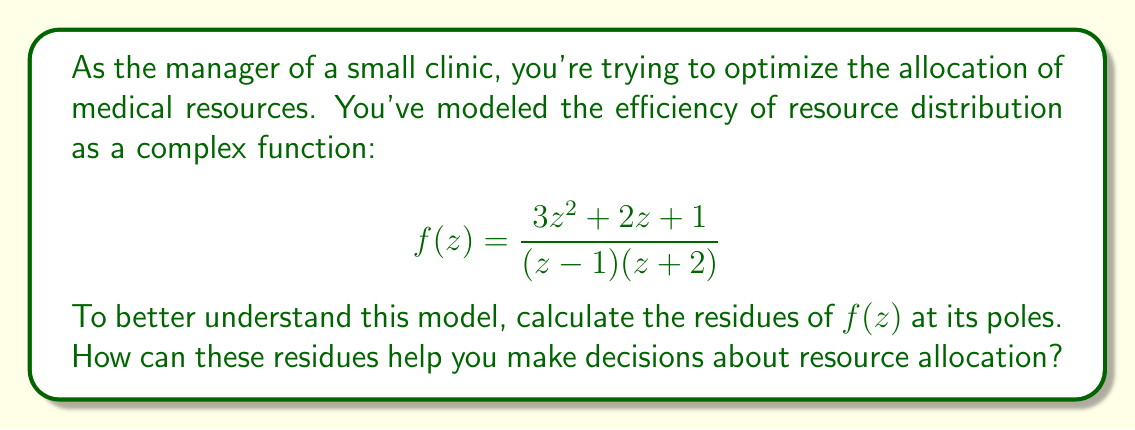Solve this math problem. Let's approach this step-by-step:

1) First, we need to identify the poles of the function. The poles occur where the denominator equals zero:
   $(z-1)(z+2) = 0$
   This gives us two simple poles: $z=1$ and $z=-2$

2) To find the residues, we'll use the formula for simple poles:
   $\text{Res}(f,a) = \lim_{z \to a} (z-a)f(z)$

3) For the pole at $z=1$:
   $$\begin{align*}
   \text{Res}(f,1) &= \lim_{z \to 1} (z-1)\frac{3z^2 + 2z + 1}{(z-1)(z+2)} \\
   &= \lim_{z \to 1} \frac{3z^2 + 2z + 1}{z+2} \\
   &= \frac{3(1)^2 + 2(1) + 1}{1+2} = \frac{6}{3} = 2
   \end{align*}$$

4) For the pole at $z=-2$:
   $$\begin{align*}
   \text{Res}(f,-2) &= \lim_{z \to -2} (z+2)\frac{3z^2 + 2z + 1}{(z-1)(z+2)} \\
   &= \lim_{z \to -2} \frac{3z^2 + 2z + 1}{z-1} \\
   &= \frac{3(-2)^2 + 2(-2) + 1}{-2-1} = \frac{12 - 4 + 1}{-3} = -3
   \end{align*}$$

5) Interpretation for resource allocation:
   - The residue at $z=1$ is positive (2), which might indicate a potential for efficient resource use or a surplus in that area.
   - The residue at $z=-2$ is negative (-3), which could suggest an area of resource deficit or inefficiency.
   - The magnitudes (2 and 3) could indicate the relative importance or impact of these areas on overall resource allocation.

These residues can help in decision-making by highlighting areas that may need more attention (negative residue) or areas that are performing well (positive residue). The manager could consider reallocating resources from areas of surplus to areas of deficit to optimize overall clinic performance.
Answer: The residues of $f(z) = \frac{3z^2 + 2z + 1}{(z-1)(z+2)}$ are:

At $z=1$: $\text{Res}(f,1) = 2$
At $z=-2$: $\text{Res}(f,-2) = -3$

These residues can guide resource allocation decisions by indicating areas of potential surplus (positive residue) and deficit (negative residue) in the clinic's operations. 